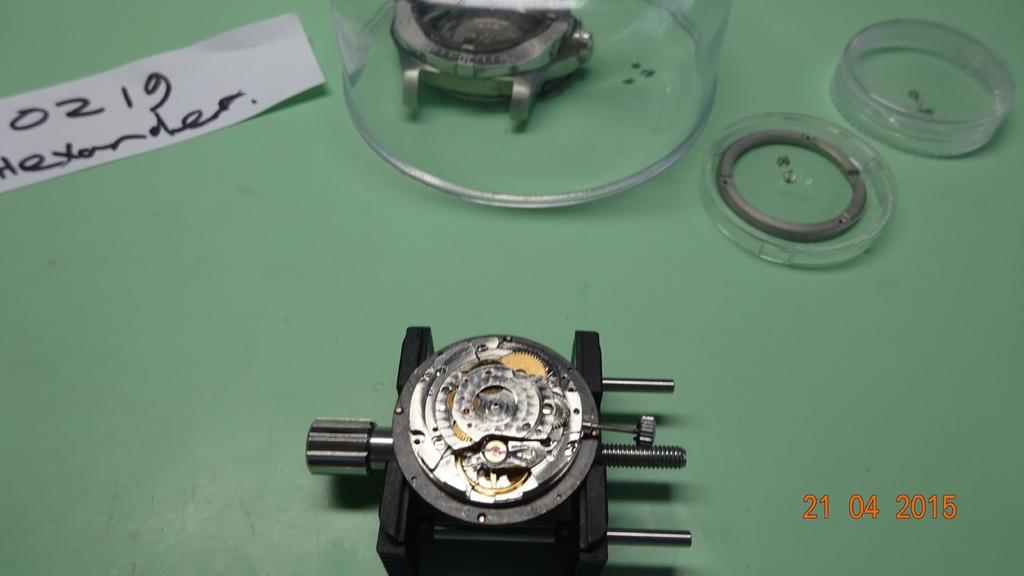<image>
Give a short and clear explanation of the subsequent image. A mechanical device is pictured from the date 21-04-2015. 